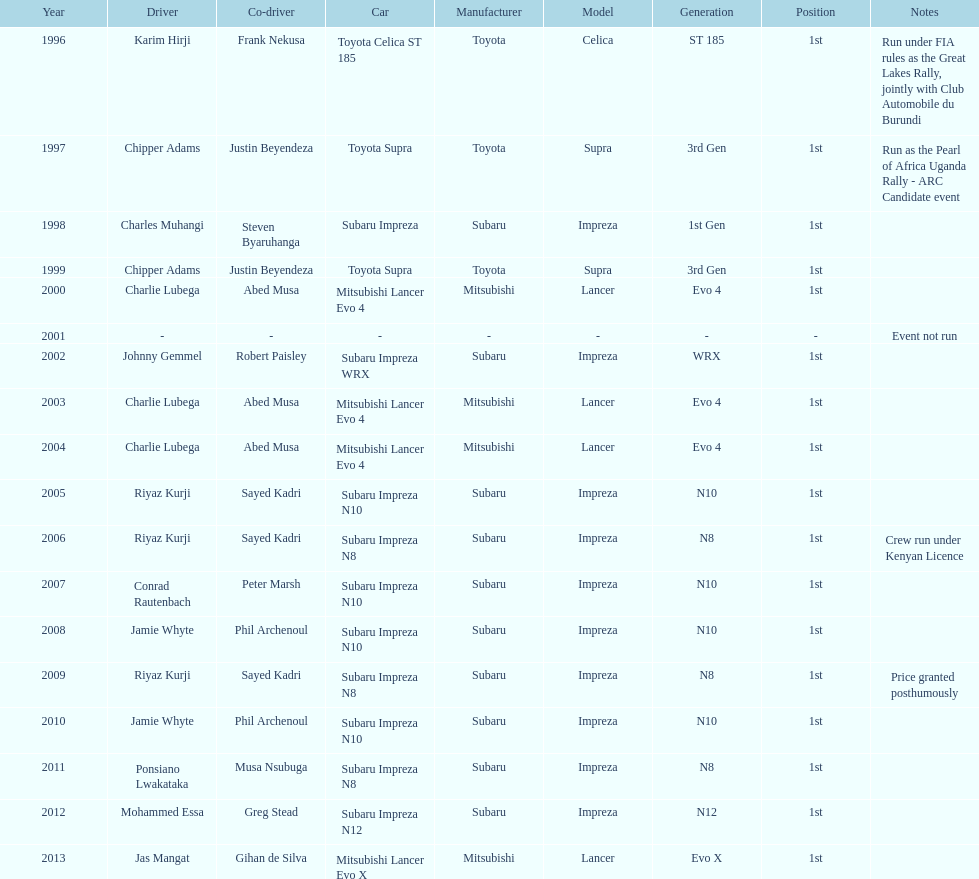Do chipper adams and justin beyendeza have more than 3 wins? No. 